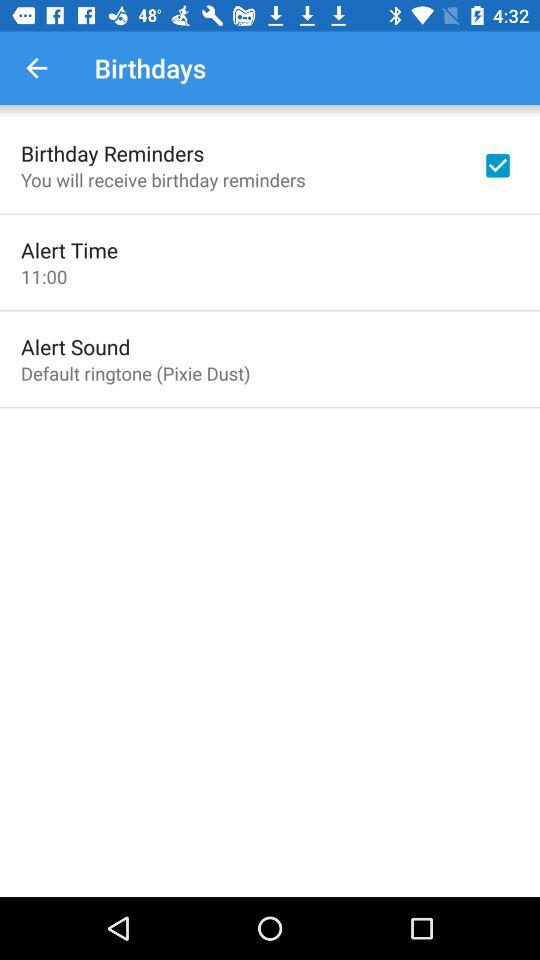Which option has been checked? The checked option is "Birthday Reminders". 